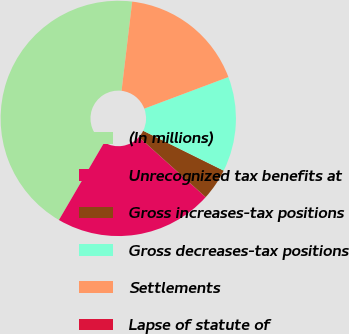Convert chart to OTSL. <chart><loc_0><loc_0><loc_500><loc_500><pie_chart><fcel>(In millions)<fcel>Unrecognized tax benefits at<fcel>Gross increases-tax positions<fcel>Gross decreases-tax positions<fcel>Settlements<fcel>Lapse of statute of<nl><fcel>43.47%<fcel>21.74%<fcel>4.35%<fcel>13.04%<fcel>17.39%<fcel>0.0%<nl></chart> 